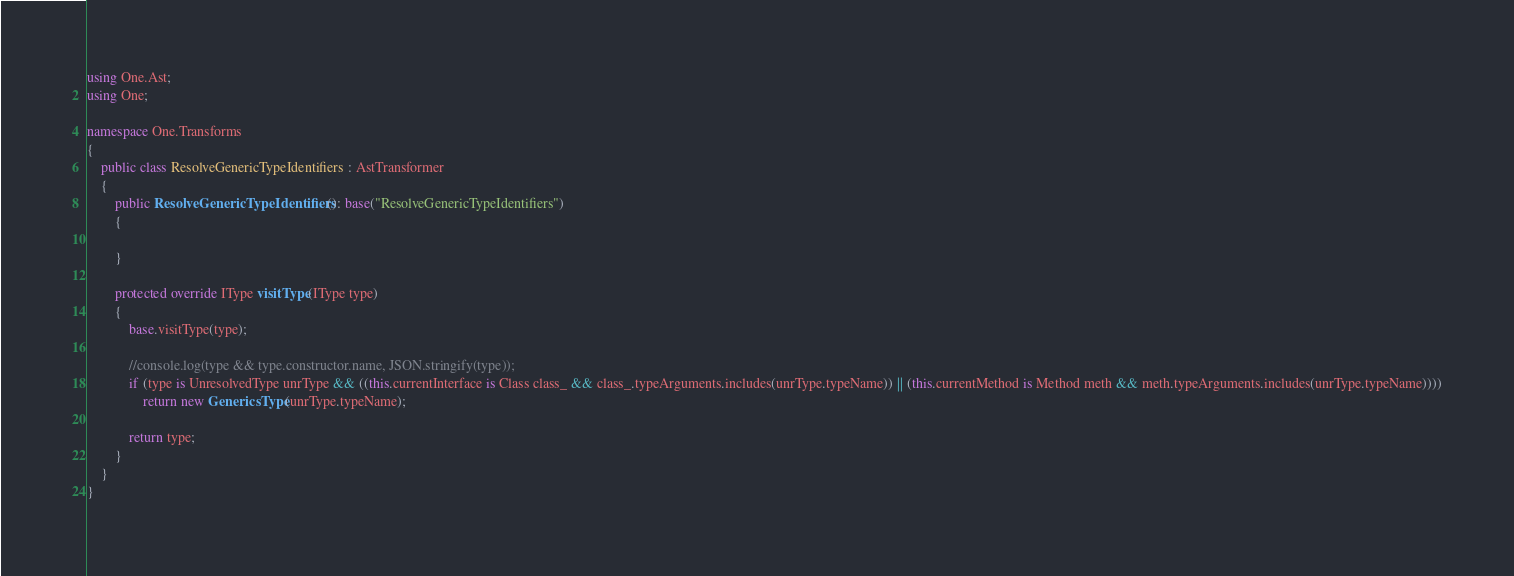Convert code to text. <code><loc_0><loc_0><loc_500><loc_500><_C#_>using One.Ast;
using One;

namespace One.Transforms
{
    public class ResolveGenericTypeIdentifiers : AstTransformer
    {
        public ResolveGenericTypeIdentifiers(): base("ResolveGenericTypeIdentifiers")
        {
            
        }
        
        protected override IType visitType(IType type)
        {
            base.visitType(type);
            
            //console.log(type && type.constructor.name, JSON.stringify(type));
            if (type is UnresolvedType unrType && ((this.currentInterface is Class class_ && class_.typeArguments.includes(unrType.typeName)) || (this.currentMethod is Method meth && meth.typeArguments.includes(unrType.typeName))))
                return new GenericsType(unrType.typeName);
            
            return type;
        }
    }
}</code> 